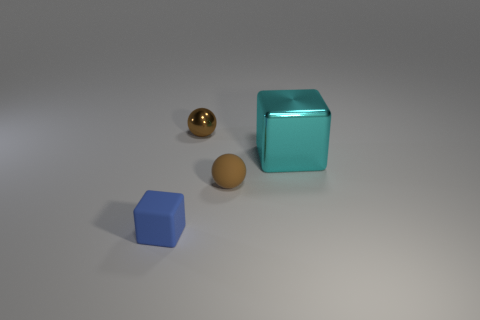Is there any indication of the setting or location of these objects? There are no clear indicators of a specific setting or location in this image; the background is neutral, and there is no contextual scenery providing clues. 